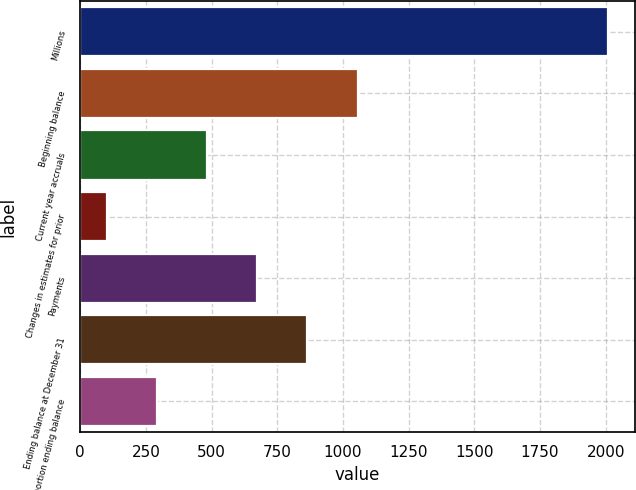Convert chart to OTSL. <chart><loc_0><loc_0><loc_500><loc_500><bar_chart><fcel>Millions<fcel>Beginning balance<fcel>Current year accruals<fcel>Changes in estimates for prior<fcel>Payments<fcel>Ending balance at December 31<fcel>Current portion ending balance<nl><fcel>2010<fcel>1055.5<fcel>482.8<fcel>101<fcel>673.7<fcel>864.6<fcel>291.9<nl></chart> 